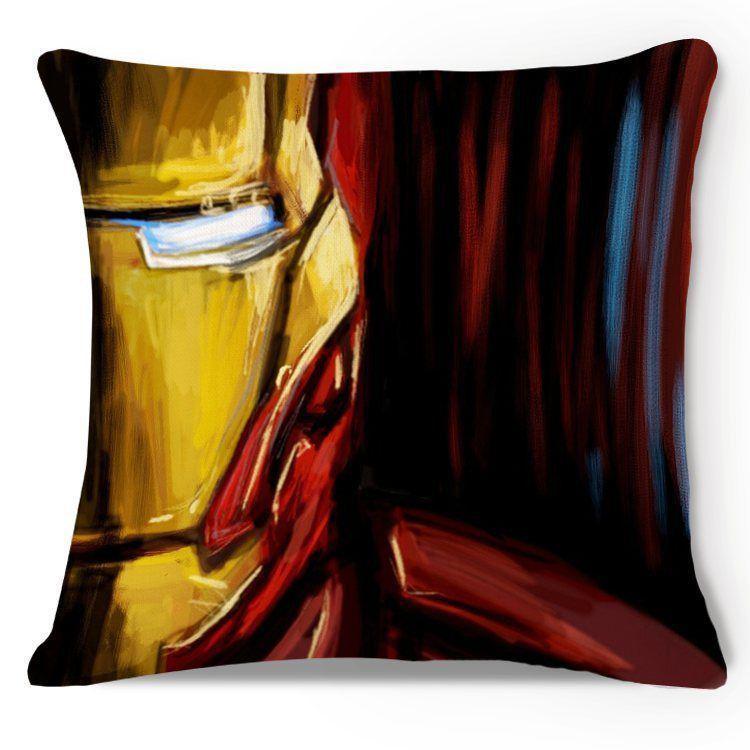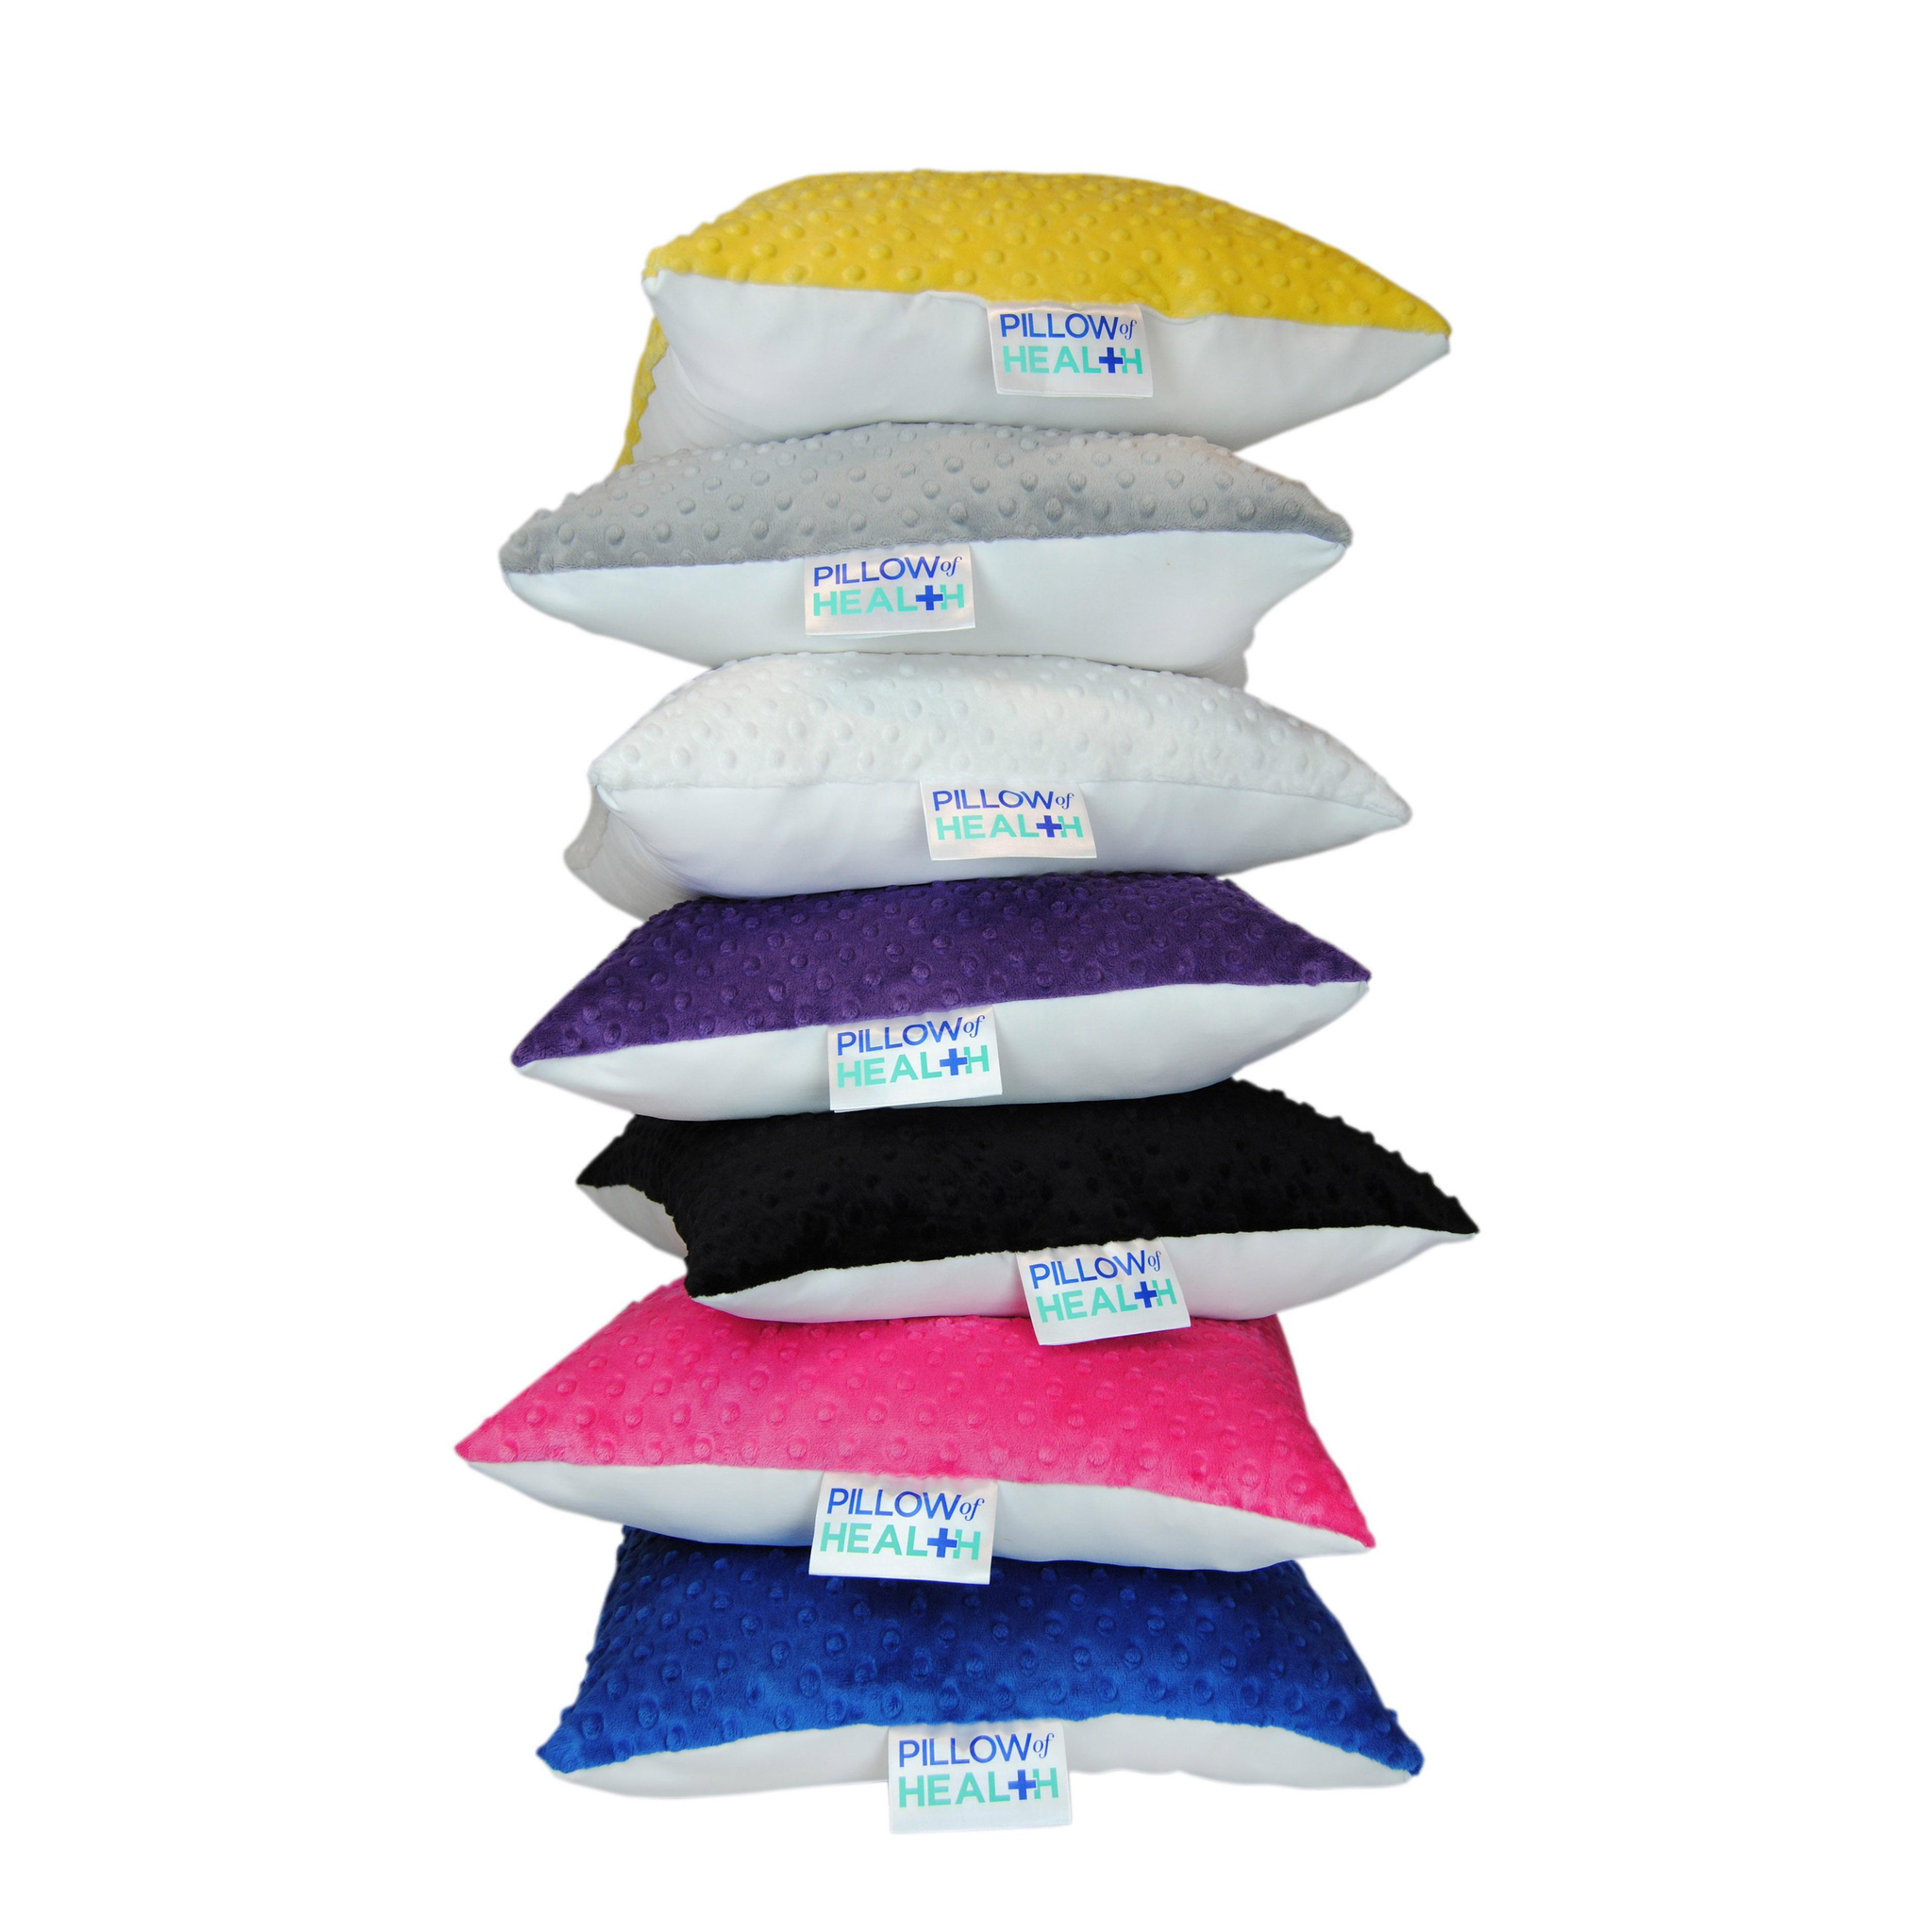The first image is the image on the left, the second image is the image on the right. Assess this claim about the two images: "The right image is a stack of at least 7 multicolored pillows, while the left image is a single square shaped pillow.". Correct or not? Answer yes or no. Yes. The first image is the image on the left, the second image is the image on the right. For the images shown, is this caption "An image shows a four-sided pillow shape with at least one animal image on it." true? Answer yes or no. No. 